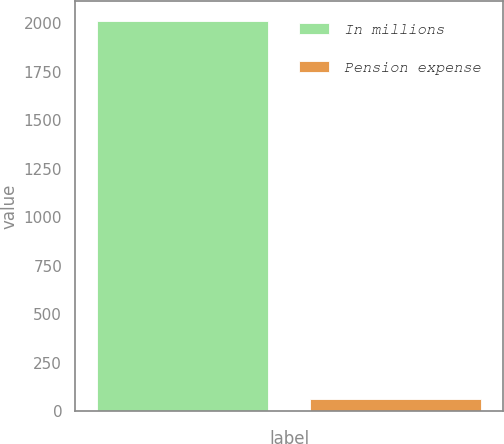<chart> <loc_0><loc_0><loc_500><loc_500><bar_chart><fcel>In millions<fcel>Pension expense<nl><fcel>2012<fcel>64<nl></chart> 